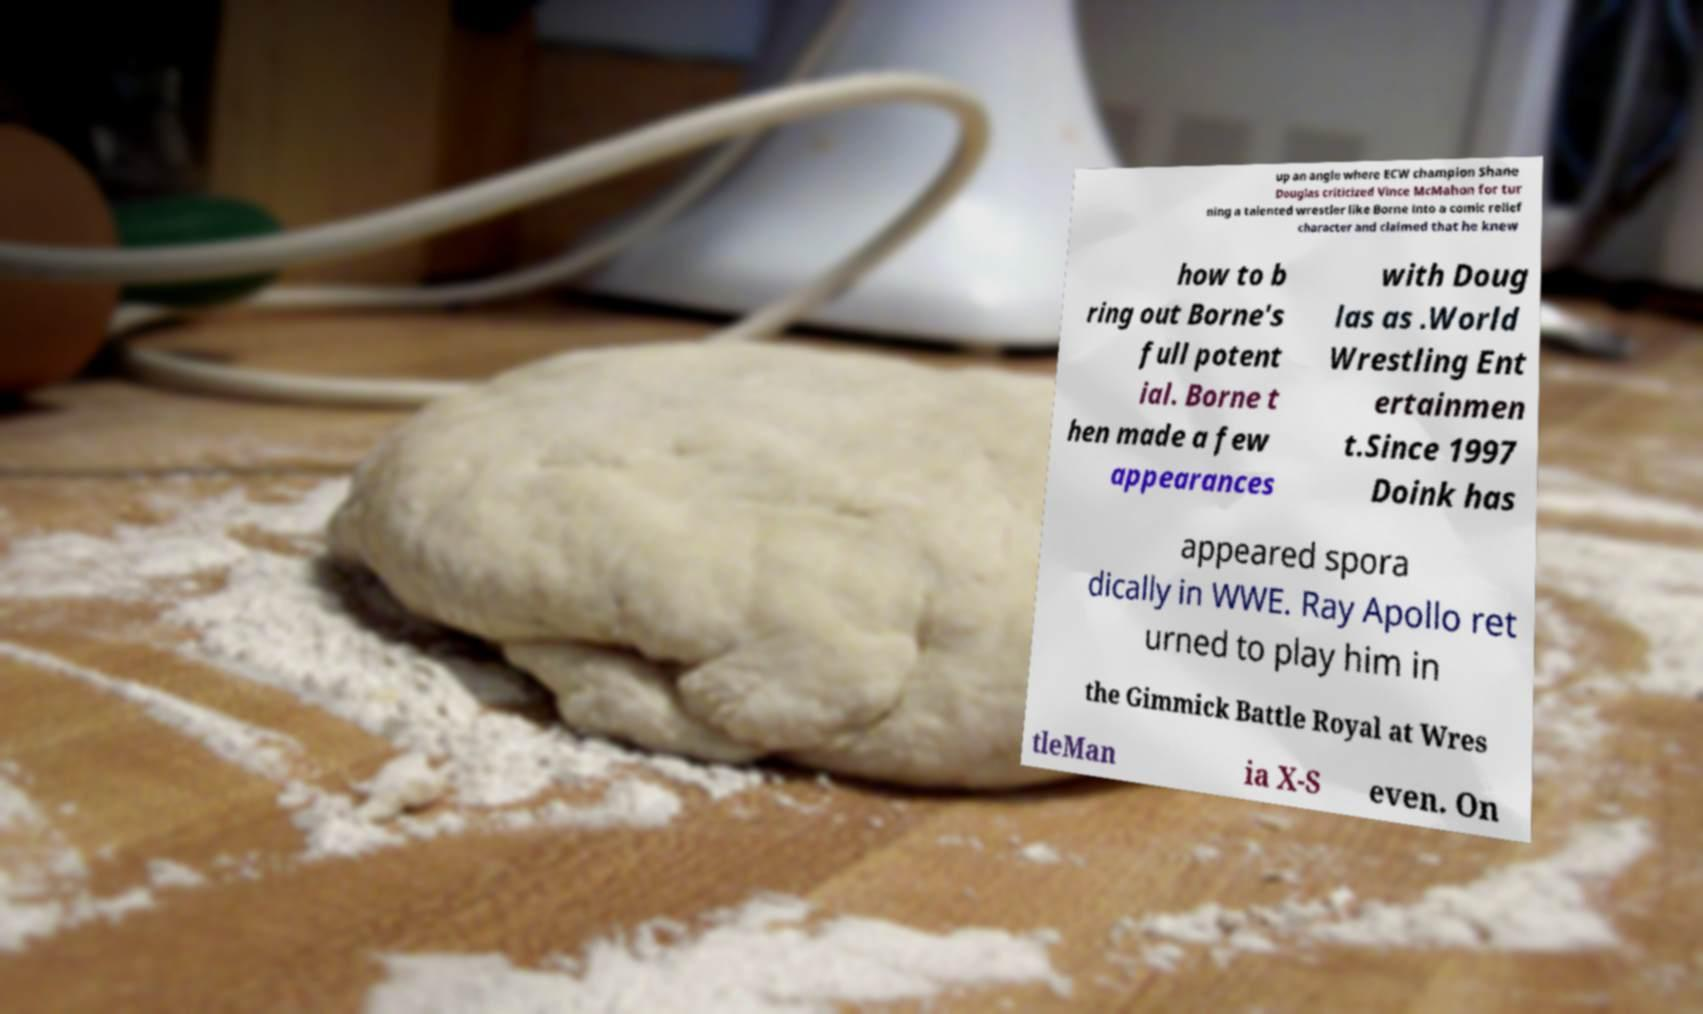Can you accurately transcribe the text from the provided image for me? up an angle where ECW champion Shane Douglas criticized Vince McMahon for tur ning a talented wrestler like Borne into a comic relief character and claimed that he knew how to b ring out Borne's full potent ial. Borne t hen made a few appearances with Doug las as .World Wrestling Ent ertainmen t.Since 1997 Doink has appeared spora dically in WWE. Ray Apollo ret urned to play him in the Gimmick Battle Royal at Wres tleMan ia X-S even. On 